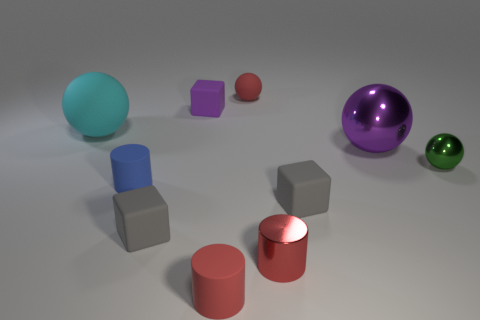How many big blue cylinders are there?
Offer a very short reply. 0. What is the shape of the small green object that is on the right side of the big cyan matte object?
Provide a succinct answer. Sphere. There is a tiny matte block that is behind the ball that is right of the big thing that is right of the blue object; what color is it?
Give a very brief answer. Purple. There is another large object that is made of the same material as the green thing; what shape is it?
Provide a short and direct response. Sphere. Are there fewer large brown objects than green objects?
Your response must be concise. Yes. Is the blue cylinder made of the same material as the big cyan object?
Your answer should be compact. Yes. How many other objects are there of the same color as the large shiny object?
Provide a short and direct response. 1. Is the number of purple cubes greater than the number of gray objects?
Your answer should be compact. No. There is a cyan matte thing; is it the same size as the gray matte object left of the small red metallic cylinder?
Your answer should be compact. No. The matte sphere to the left of the small blue matte thing is what color?
Your answer should be very brief. Cyan. 